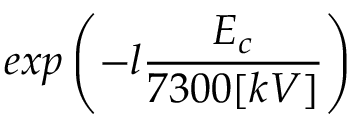<formula> <loc_0><loc_0><loc_500><loc_500>e x p \left ( - l \frac { E _ { c } } { 7 3 0 0 [ k V ] } \right )</formula> 